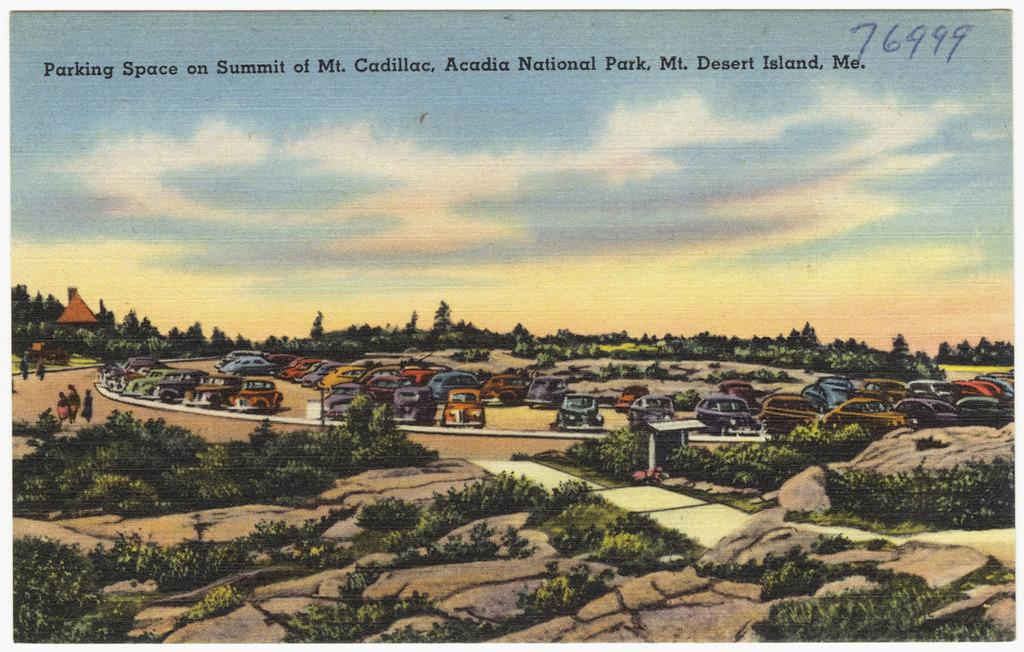<image>
Render a clear and concise summary of the photo. Postcard from the parking space on Summit of Mt Cadillac in Acadia National Park. 